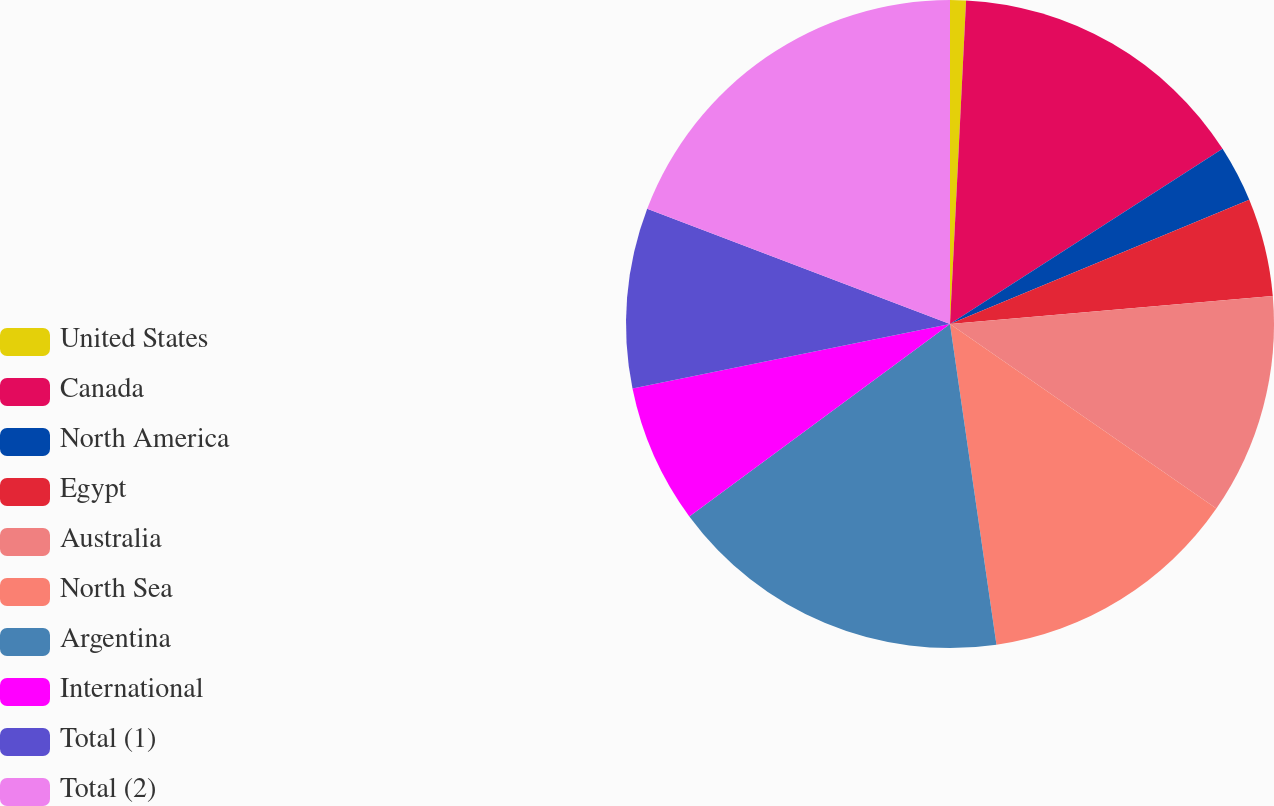Convert chart to OTSL. <chart><loc_0><loc_0><loc_500><loc_500><pie_chart><fcel>United States<fcel>Canada<fcel>North America<fcel>Egypt<fcel>Australia<fcel>North Sea<fcel>Argentina<fcel>International<fcel>Total (1)<fcel>Total (2)<nl><fcel>0.79%<fcel>15.12%<fcel>2.83%<fcel>4.88%<fcel>11.02%<fcel>13.07%<fcel>17.17%<fcel>6.93%<fcel>8.98%<fcel>19.21%<nl></chart> 